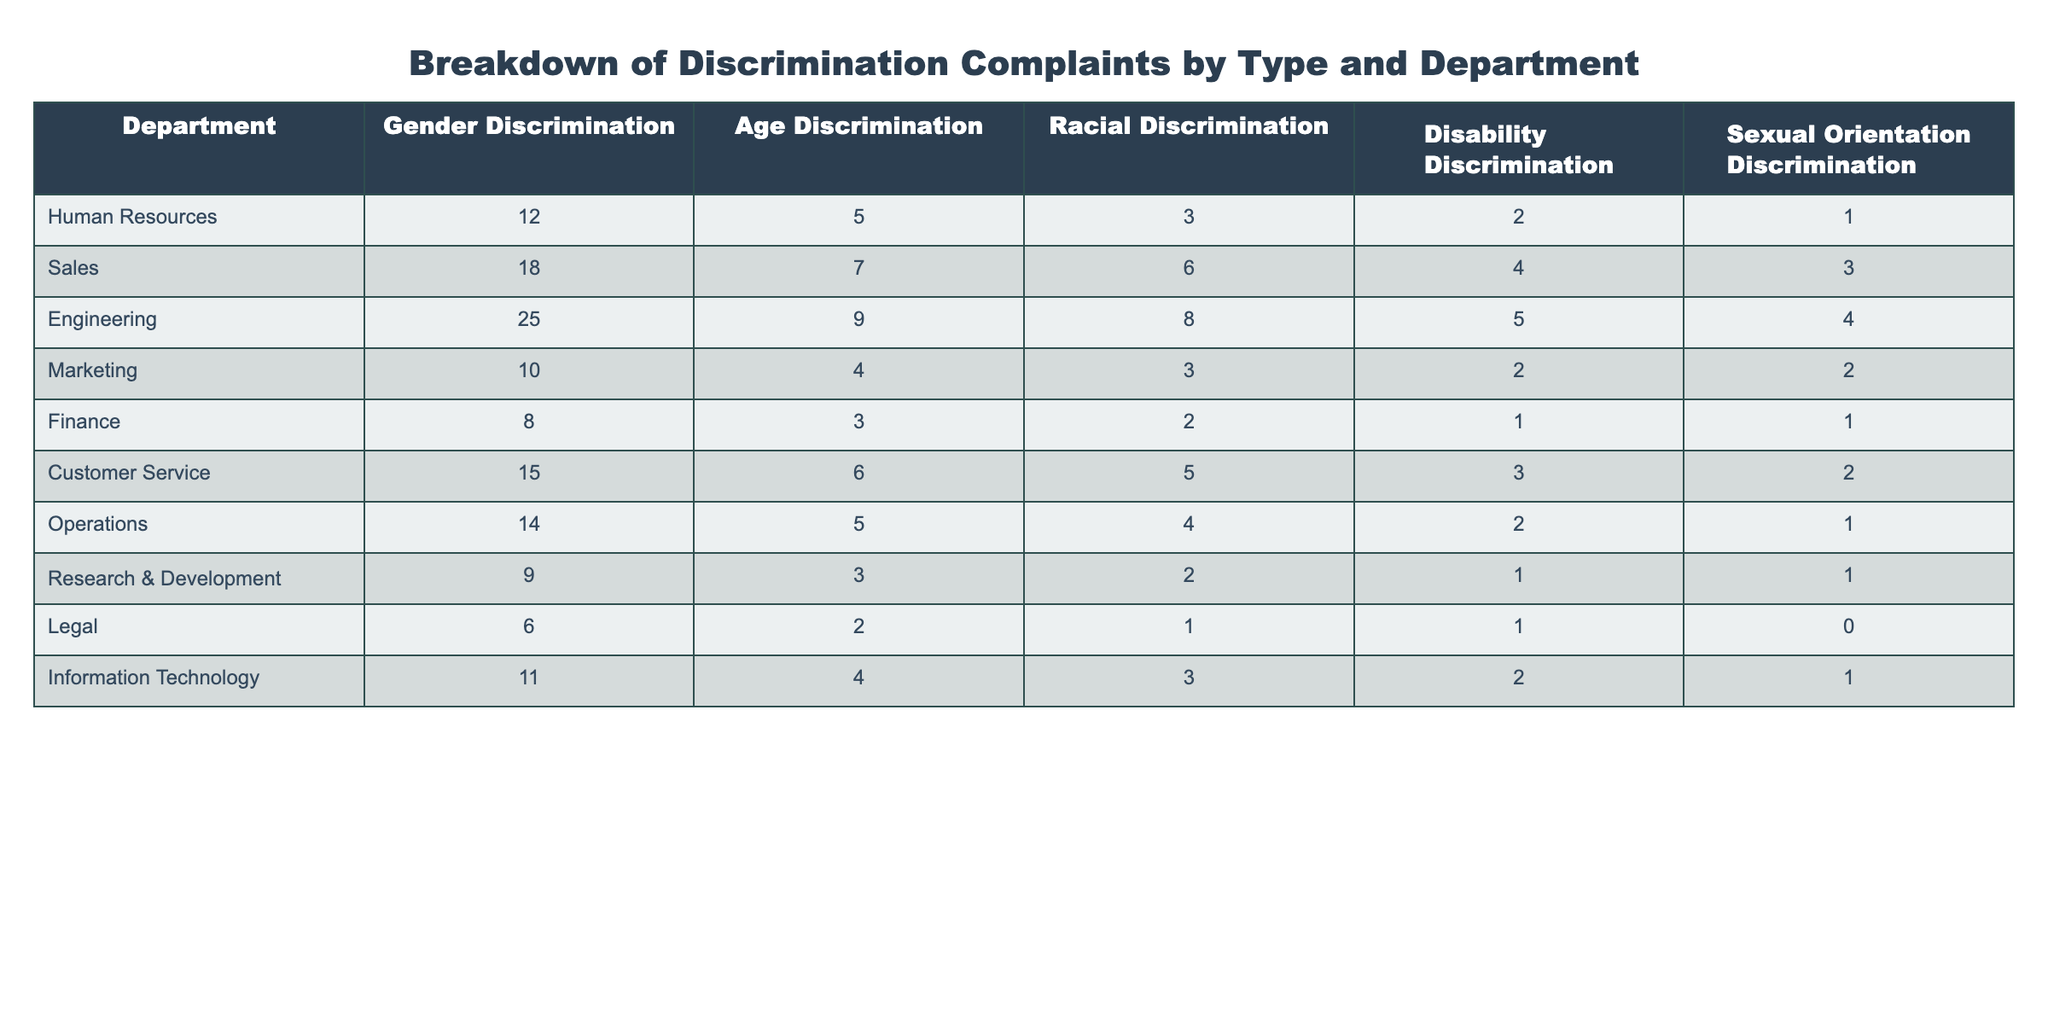What department has the highest number of gender discrimination complaints? Looking at the table, the Engineering department has 25 gender discrimination complaints, which is more than any other department.
Answer: Engineering How many total discrimination complaints were reported in the Sales department? To find the total complaints in the Sales department, sum all values: 18 (Gender) + 7 (Age) + 6 (Racial) + 4 (Disability) + 3 (Sexual Orientation) = 38.
Answer: 38 Which department has the fewest number of disability discrimination complaints? The Legal department has only 1 disability discrimination complaint, which is the lowest when comparing all departments.
Answer: Legal What is the average number of racial discrimination complaints across all departments? Sum all racial discrimination complaints: 3 + 6 + 8 + 3 + 2 + 5 + 4 + 2 + 1 + 3 = 33 complaints. Divide by the number of departments (10): 33/10 = 3.3.
Answer: 3.3 Is there any department with zero complaints for sexual orientation discrimination? By checking the table, the Legal department has 0 complaints for sexual orientation discrimination.
Answer: Yes What is the total number of discrimination complaints in the Human Resources department? For Human Resources, the total is 12 (Gender) + 5 (Age) + 3 (Racial) + 2 (Disability) + 1 (Sexual Orientation) = 23.
Answer: 23 Which type of discrimination had the highest total across all departments? Summing each type: Gender (12+18+25+10+8+15+14+9+6+11=  136), Age (5+7+9+4+3+6+5+3+2+4= 58), Racial (3+6+8+3+2+5+4+2+1+3= 38), Disability (2+4+5+2+1+3+2+1+1+2= 23), Sexual Orientation (1+3+4+2+1+2+1+1+0+1= 16). Gender discrimination has the highest total with 136 complaints.
Answer: Gender Discrimination What is the difference between the number of racial discrimination complaints in Engineering and Finance? Engineering has 8 racial discrimination complaints, while Finance has 2. The difference is 8 - 2 = 6.
Answer: 6 Which department reported more complaints for age and disability discrimination combined, Sales or Customer Service? Sales reported 7 (Age) + 4 (Disability) = 11, while Customer Service reported 6 (Age) + 3 (Disability) = 9. Sales has more combined complaints.
Answer: Sales 